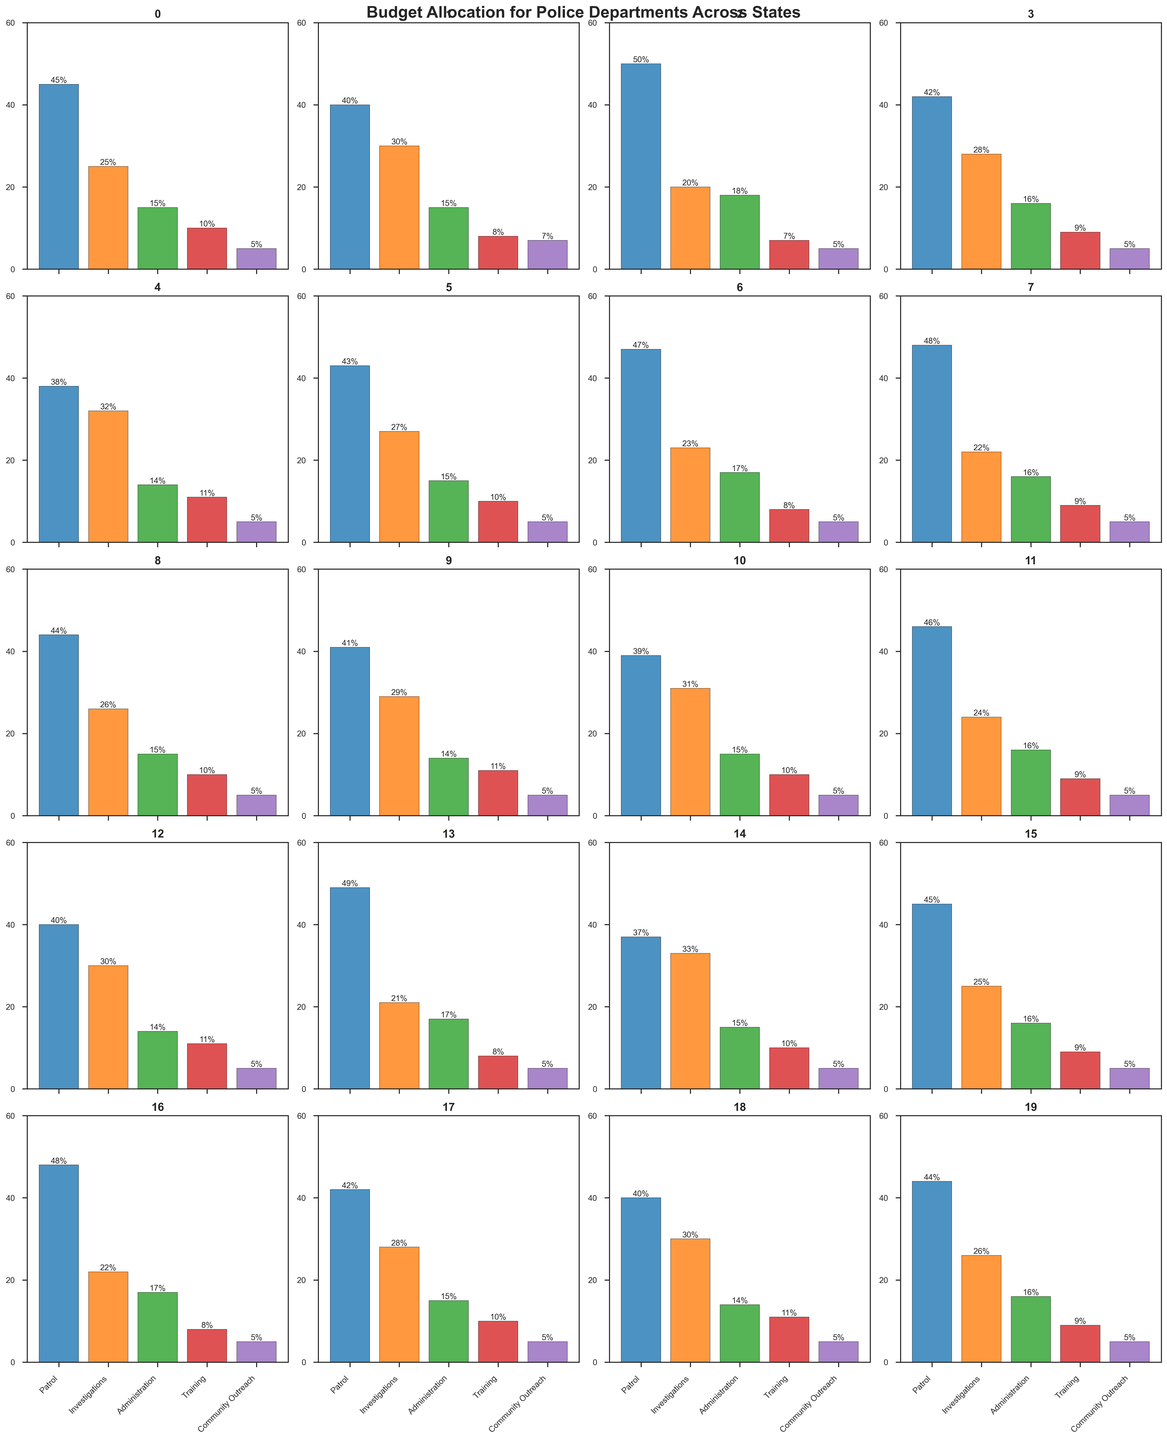What's the average percentage allocation for the community outreach across all states? Sum the percentage allocation for the community outreach for all states (5% + 7% + 5% + 5% + 5% + 5% + 5% + 5% + 5% + 5% + 5% + 5% + 5% + 5% + 5% + 5% + 5% + 5% + 5% + 5% = 100%). Then, divide by the number of states (20). The average is 100 / 20 = 5%.
Answer: 5% Which state allocates the highest percentage to patrol? Look at the subplot bars for each state and identify the tallest bar under the "Patrol" category. Arizona has the highest percentage for patrol at 49%.
Answer: Arizona What is the difference in the percentage allocation to investigations between California and Illinois? California allocates 30% and Illinois allocates 32% to investigations. The difference is 32% - 30% = 2%.
Answer: 2% Which department typically gets the least budget across all states? Observe the shortest bars consistently across all state subplots. Community Outreach typically has the least budget, with many states allocating just 5%.
Answer: Community Outreach What is the total percentage allocation for administrative costs across Texas, Florida, and Ohio? Add the administrative allocations: Texas (18%) + Florida (16%) + Ohio (17%) = 18% + 16% + 17% = 51%.
Answer: 51% Which state has the most balanced budget allocation, with the smallest difference between the highest and lowest allocations? Compare the ranges (difference between the highest and lowest percentages) for each state's subplot. Massachusetts has a very balanced budget, with the highest at 33% and the lowest at 5%, resulting in a range of 33% - 5% = 28%.
Answer: Massachusetts How does the average percentage allocation to investigations compare to that of training across all states? First, sum the percentage allocations for investigations across all states. Then, sum the allocations for training. Divide each total by the number of states (20) to get the averages. Investigations: (25% + 30% + ... + 26%) / 20 = 26.25%. Training: (10% + 8% + ... + 9%) / 20 = 9%. The average allocation to investigations (26.25%) is greater than that to training (9%).
Answer: Investigations > Training For how many states is "Patrol" the highest budget allocation? Count the number of states where the "Patrol" bar is the tallest in its subplot. Patrol is the highest allocation in 15 states: New York, California, Texas, Florida, Pennsylvania, Ohio, Georgia, North Carolina, Virginia, Washington, Arizona, Indiana, Maryland, Wisconsin, Tennessee.
Answer: 15 states 